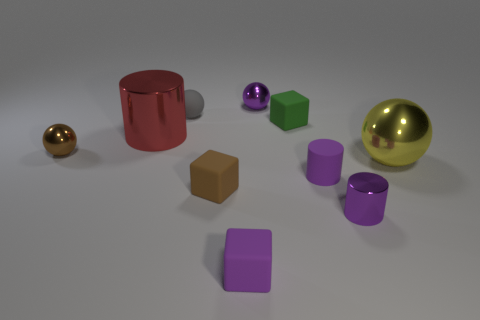What is the color of the metallic thing that is on the right side of the small green rubber thing and to the left of the large metal sphere?
Ensure brevity in your answer.  Purple. There is a big cylinder; is it the same color as the tiny metallic ball behind the tiny green thing?
Give a very brief answer. No. There is a rubber object that is behind the purple rubber cylinder and right of the gray matte thing; what is its size?
Ensure brevity in your answer.  Small. How many other things are the same color as the large shiny sphere?
Your response must be concise. 0. There is a purple metallic object that is to the left of the purple thing to the right of the purple matte object behind the brown matte object; how big is it?
Keep it short and to the point. Small. Are there any small metallic things behind the purple sphere?
Your answer should be very brief. No. There is a gray rubber ball; is it the same size as the sphere that is right of the small purple metal sphere?
Give a very brief answer. No. How many other objects are the same material as the gray thing?
Offer a terse response. 4. There is a tiny metallic thing that is both to the left of the small green matte object and to the right of the brown sphere; what shape is it?
Your answer should be compact. Sphere. Do the purple cylinder right of the small rubber cylinder and the shiny ball behind the big red metallic cylinder have the same size?
Give a very brief answer. Yes. 